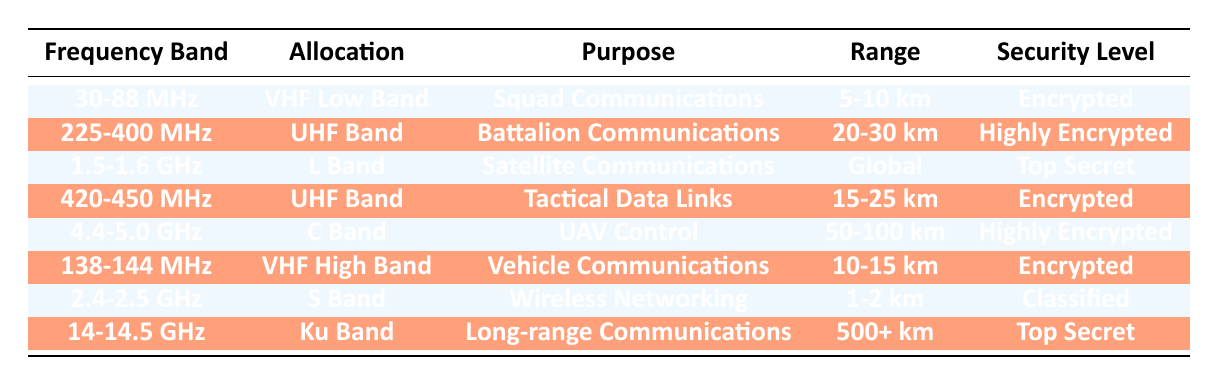What is the purpose of the frequency band 30-88 MHz? The table indicates that the purpose of the frequency band 30-88 MHz is "Squad Communications." I found this information directly in the "Purpose" column corresponding to the "Frequency Band" row that matches 30-88 MHz.
Answer: Squad Communications Which frequency band is used for UAV control? According to the table, the frequency band used for UAV control is 4.4-5.0 GHz, as stated in the "Allocation" column under "UAV Control."
Answer: 4.4-5.0 GHz Is the security level for Tactical Data Links encrypted? The table lists the security level for Tactical Data Links as "Encrypted." This confirms that it meets the condition of being encrypted, hence the answer is true.
Answer: Yes What is the average range of communications for the UHF Band frequency allocations? There are two UHF Band allocations in the table: 225-400 MHz (20-30 km) and 420-450 MHz (15-25 km). To find the average range, I convert the ranges to a numerical format: 20-30 km averages to 25 km, and 15-25 km averages to 20 km. Thus, the average of these two is (25 + 20) / 2 = 22.5 km, which makes the final answer 22.5 km.
Answer: 22.5 km What security level is assigned to the S Band? The table states the security level for the S Band (2.4-2.5 GHz) as "Classified," which is a specific level of security in the context provided.
Answer: Classified Which frequency band offers the longest range for communications? The table indicates that the Ku Band (14-14.5 GHz) has a range of "500+ km," which is the longest range compared to all other bands listed. This was derived by comparing the "Range" column of each frequency band.
Answer: 14-14.5 GHz Are vehicle communications secured with encryption? According to the table, vehicle communications (138-144 MHz) have a security level marked as "Encrypted." Therefore, the statement is true based on the information presented.
Answer: Yes Which communication purpose has the highest security level? The table shows two "Top Secret" security levels: L Band for Satellite Communications and Ku Band for Long-range Communications. Both have the highest security level designation in the table, which requires checking each security level and determining the purposes.
Answer: Satellite Communications and Long-range Communications 